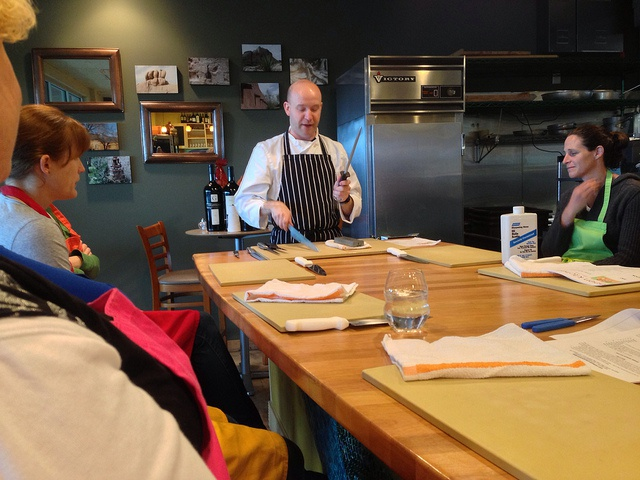Describe the objects in this image and their specific colors. I can see dining table in orange and tan tones, people in orange, tan, and black tones, people in orange, black, maroon, and brown tones, people in orange, black, lavender, darkgray, and lightpink tones, and refrigerator in orange, gray, black, and lightblue tones in this image. 